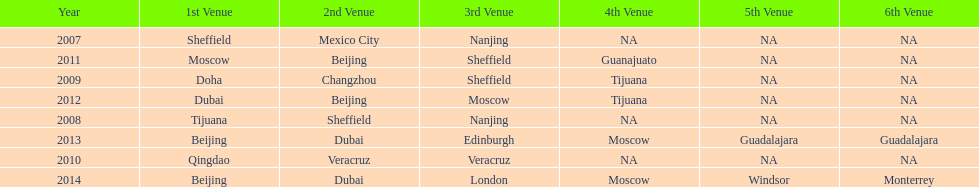In list of venues, how many years was beijing above moscow (1st venue is above 2nd venue, etc)? 3. 